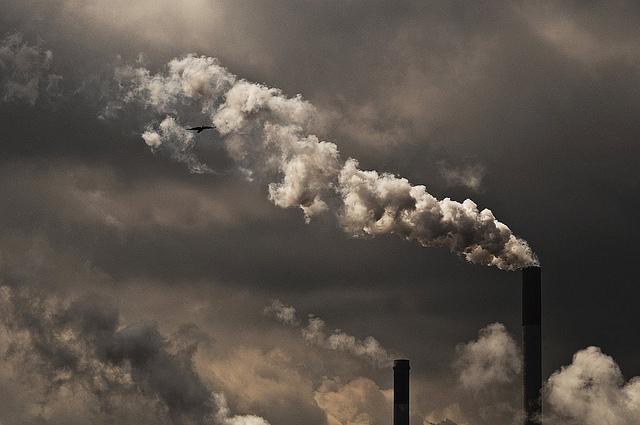Where is the smoke coming from?
Short answer required. Smoke stacks. What color is the sky?
Keep it brief. Gray. What is white in the sky?
Quick response, please. Smoke. Is the sky gray?
Keep it brief. Yes. Where are the planes?
Keep it brief. Sky. What kind of aircraft is flying in the clouds?
Keep it brief. Bird. What is the color of the sky?
Be succinct. Gray. Are there any visible animals?
Concise answer only. No. 